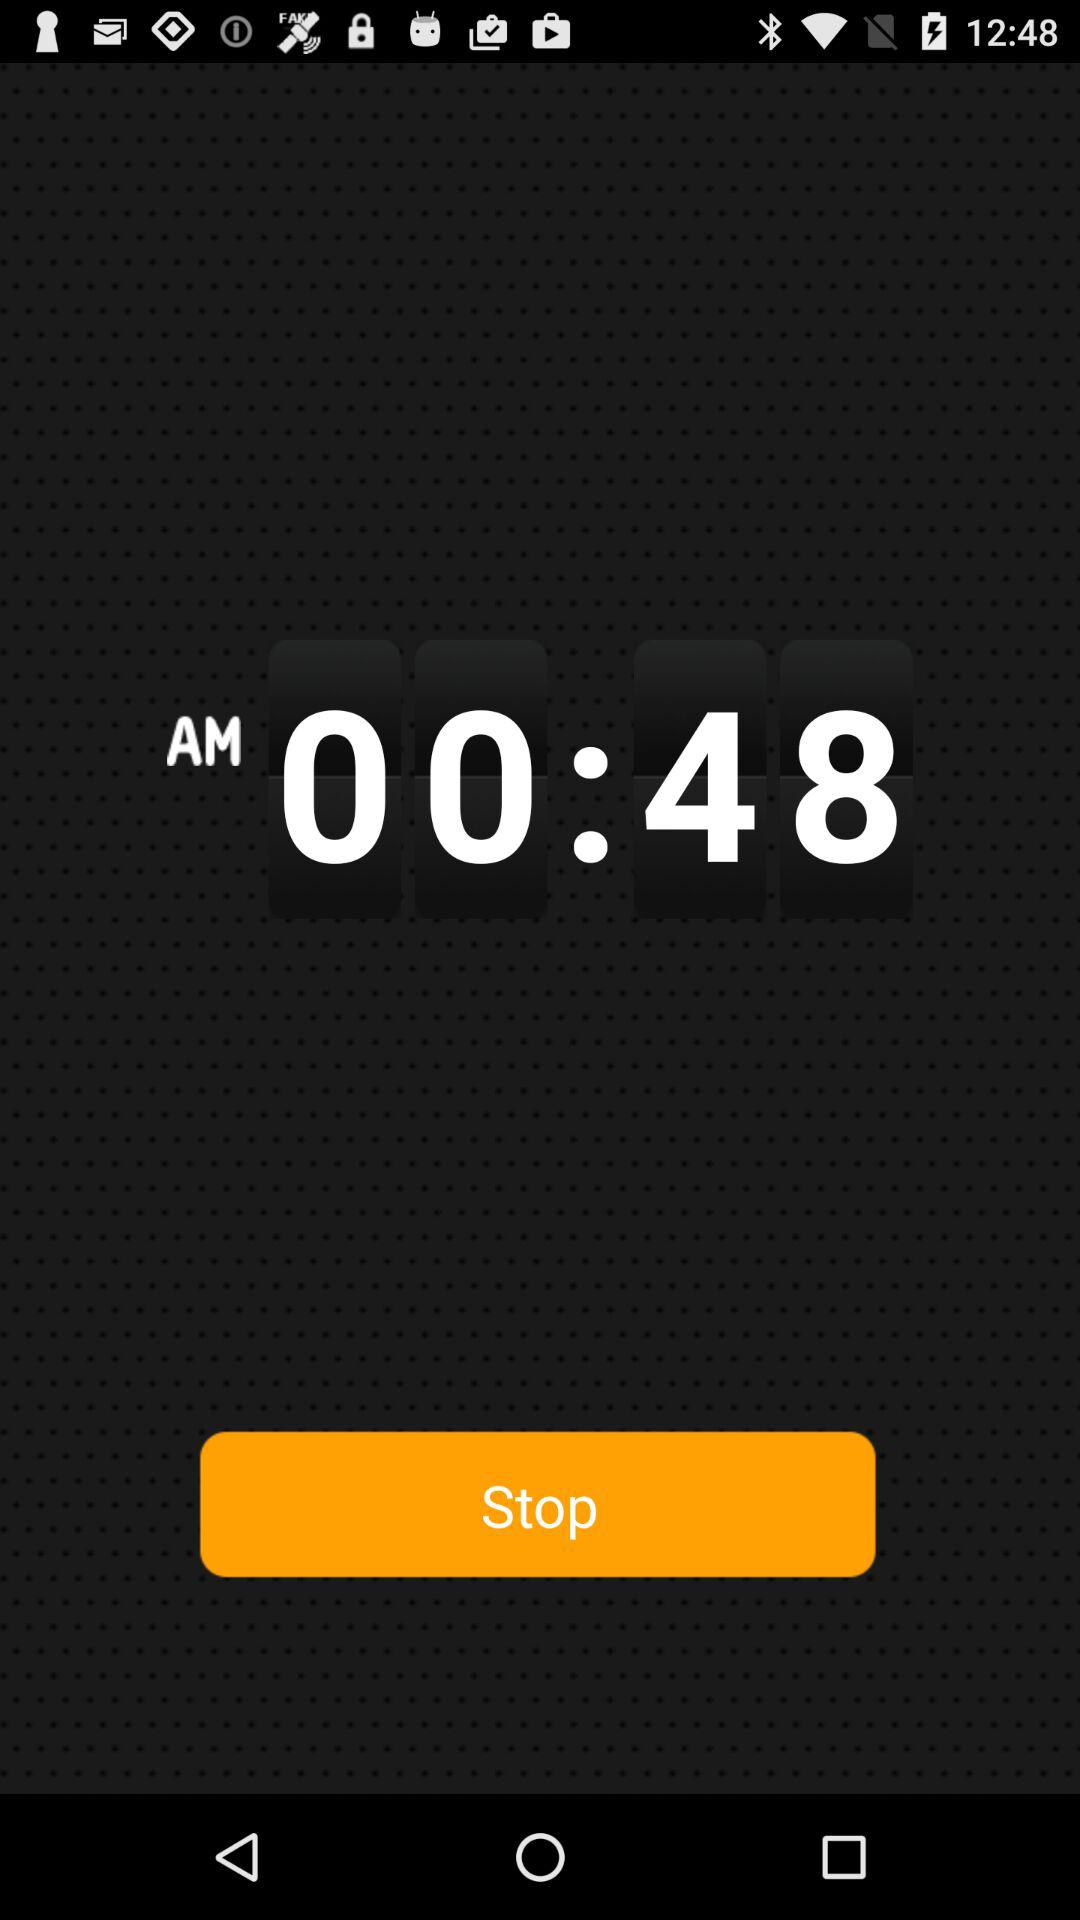What is the displayed time? The displayed time is 00:48 AM. 